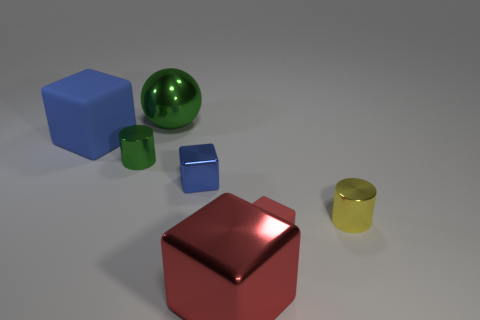Which objects appear to be made of metal? There are two objects that appear to be made of metal: the largest cube, which is red, and the smaller blue cube. 